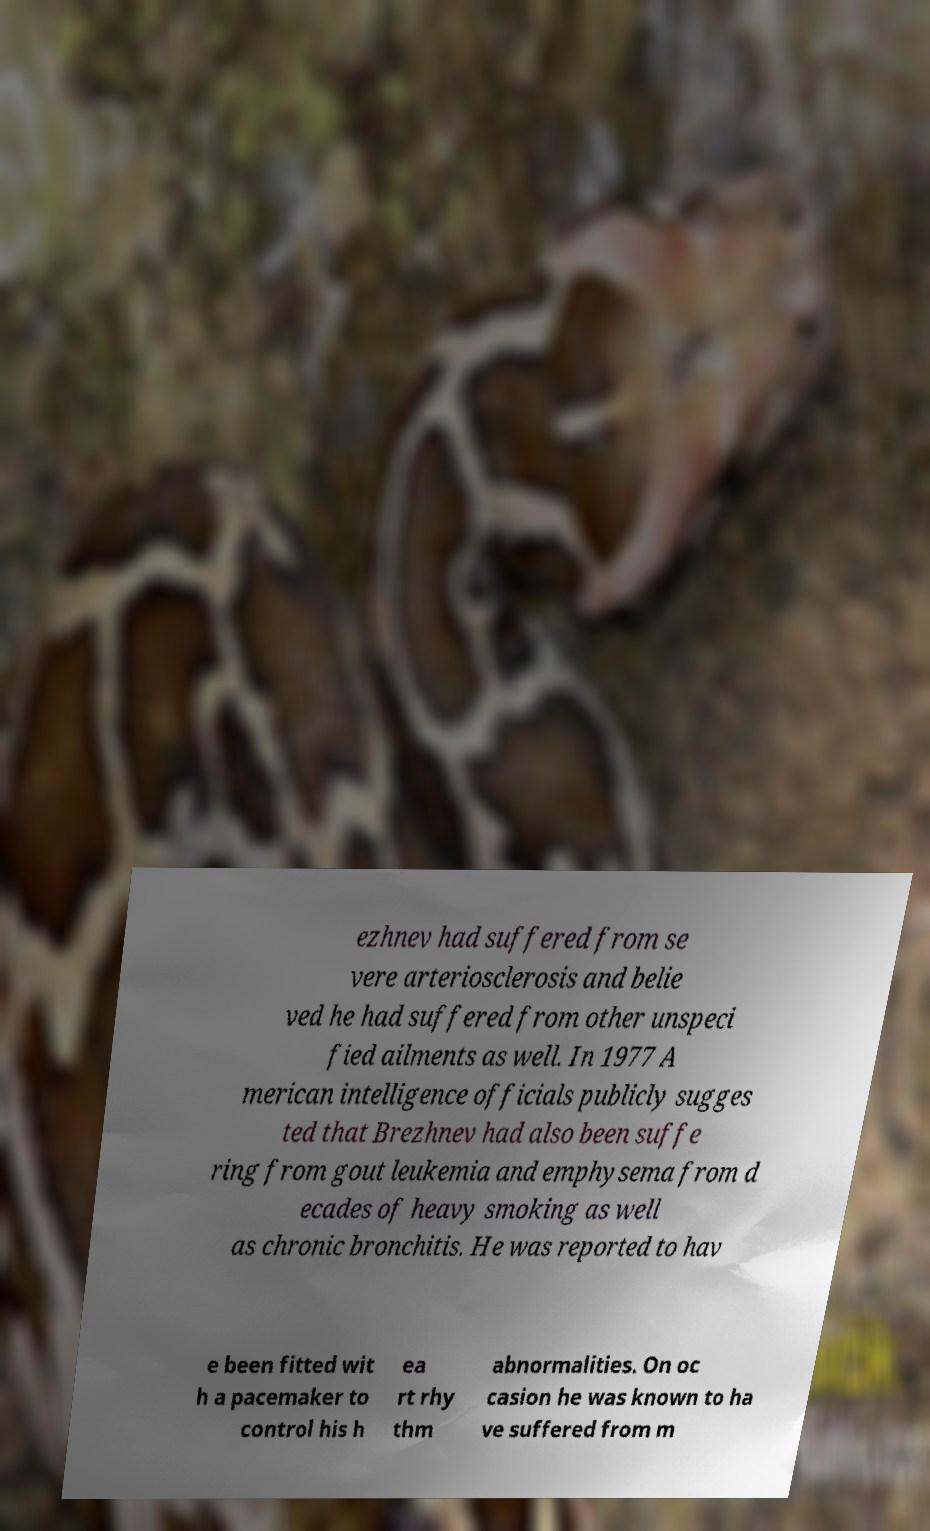I need the written content from this picture converted into text. Can you do that? ezhnev had suffered from se vere arteriosclerosis and belie ved he had suffered from other unspeci fied ailments as well. In 1977 A merican intelligence officials publicly sugges ted that Brezhnev had also been suffe ring from gout leukemia and emphysema from d ecades of heavy smoking as well as chronic bronchitis. He was reported to hav e been fitted wit h a pacemaker to control his h ea rt rhy thm abnormalities. On oc casion he was known to ha ve suffered from m 